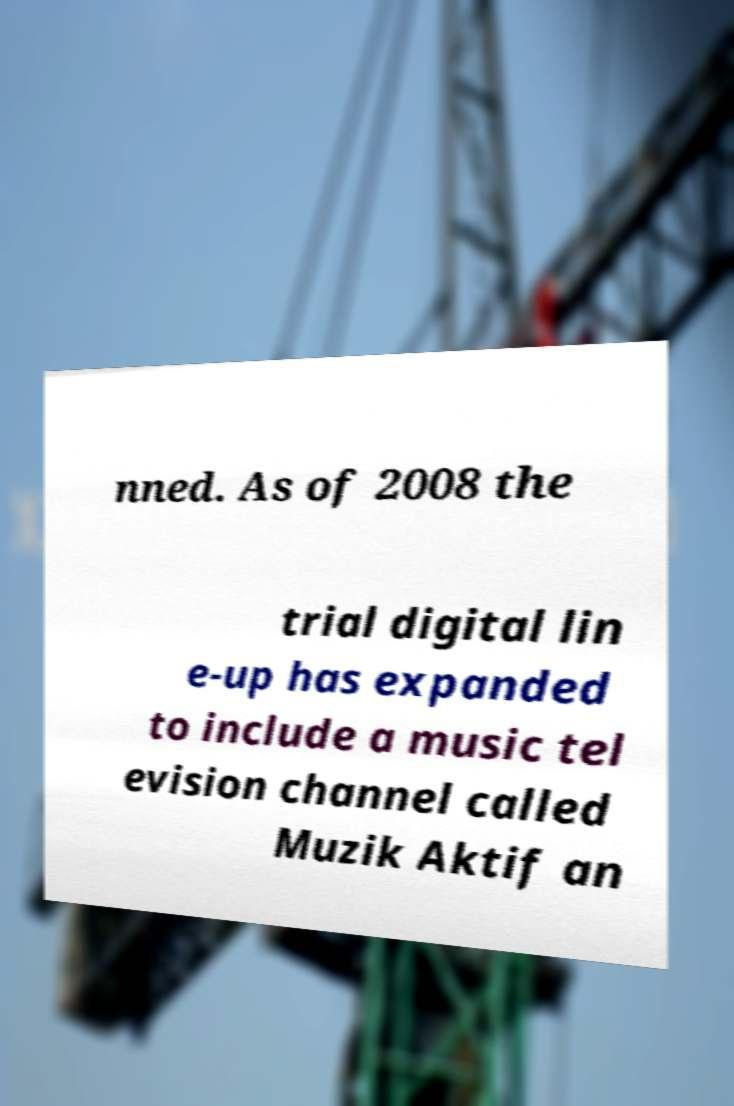Could you assist in decoding the text presented in this image and type it out clearly? nned. As of 2008 the trial digital lin e-up has expanded to include a music tel evision channel called Muzik Aktif an 